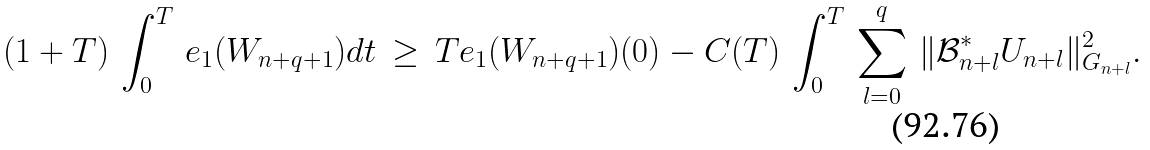Convert formula to latex. <formula><loc_0><loc_0><loc_500><loc_500>( 1 + T ) \, \int _ { 0 } ^ { T } \, e _ { 1 } ( W _ { n + q + 1 } ) d t \, \geq \, T e _ { 1 } ( W _ { n + q + 1 } ) ( 0 ) - C ( T ) \, \int _ { 0 } ^ { T } \, \sum _ { l = 0 } ^ { q } \, \| \mathcal { B } _ { n + l } ^ { \ast } U _ { n + l } \| _ { G _ { n + l } } ^ { 2 } .</formula> 